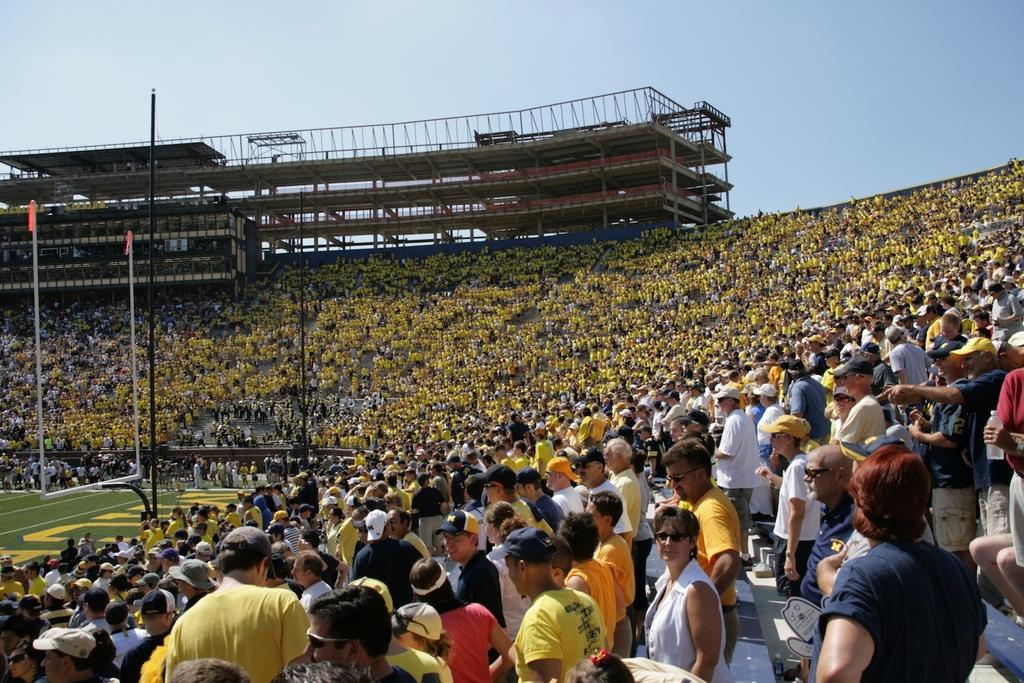What is the main setting of the image? The main setting of the image is a stadium. What objects can be seen in the stadium? There are poles and a flag visible in the image. What structures are present in the image? There is a building and stairs visible in the image. What part of the natural environment is visible in the image? The sky is visible at the top of the image. What is the ground condition in the image? There is ground visible in the image. Can you see any steam coming from the cow in the image? There is no cow or steam present in the image. What type of truck is parked near the building in the image? There is no truck present in the image. 